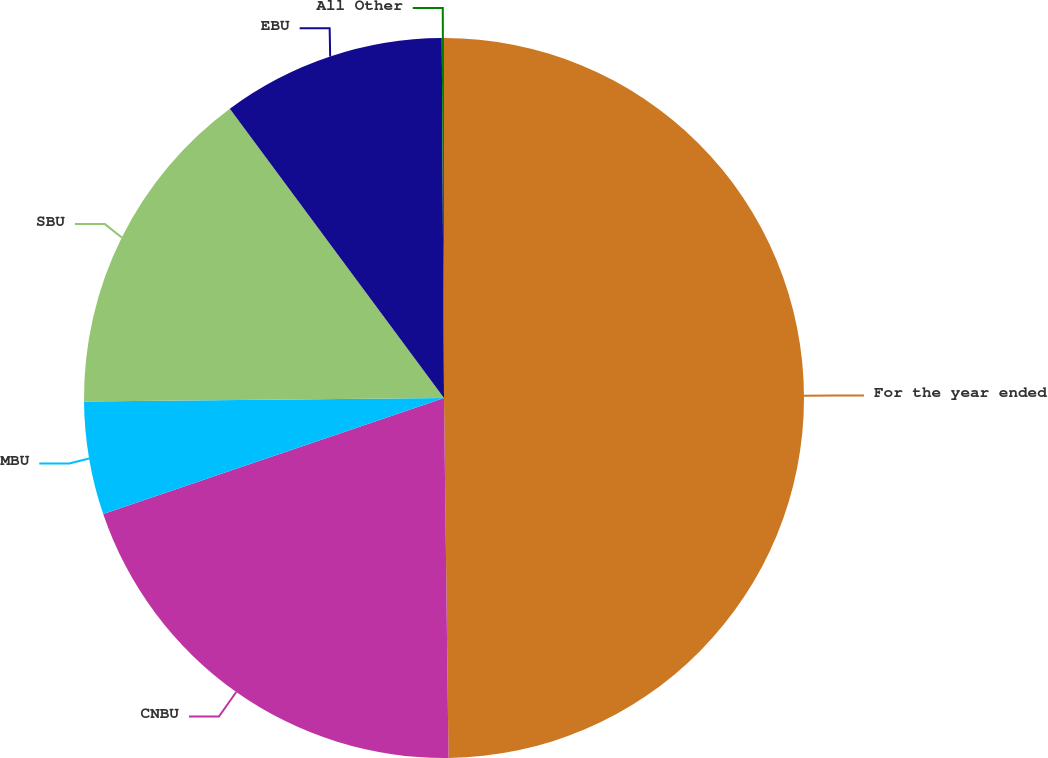<chart> <loc_0><loc_0><loc_500><loc_500><pie_chart><fcel>For the year ended<fcel>CNBU<fcel>MBU<fcel>SBU<fcel>EBU<fcel>All Other<nl><fcel>49.8%<fcel>19.98%<fcel>5.07%<fcel>15.01%<fcel>10.04%<fcel>0.1%<nl></chart> 